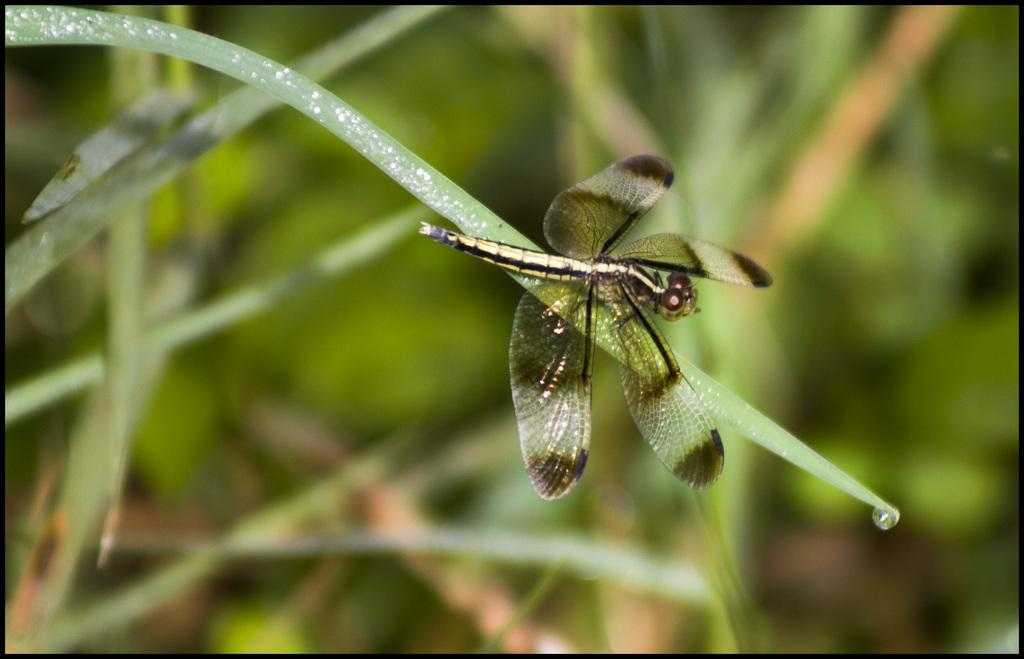What type of insect is present in the image? There is a dragonfly in the image. Where is the dragonfly located in the image? The dragonfly is sitting on the leaf of a plant. What type of actor is sitting on the leaf of the plant in the image? There is no actor present in the image; it features a dragonfly sitting on the leaf of a plant. What type of pickle is visible in the image? There is no pickle present in the image. 